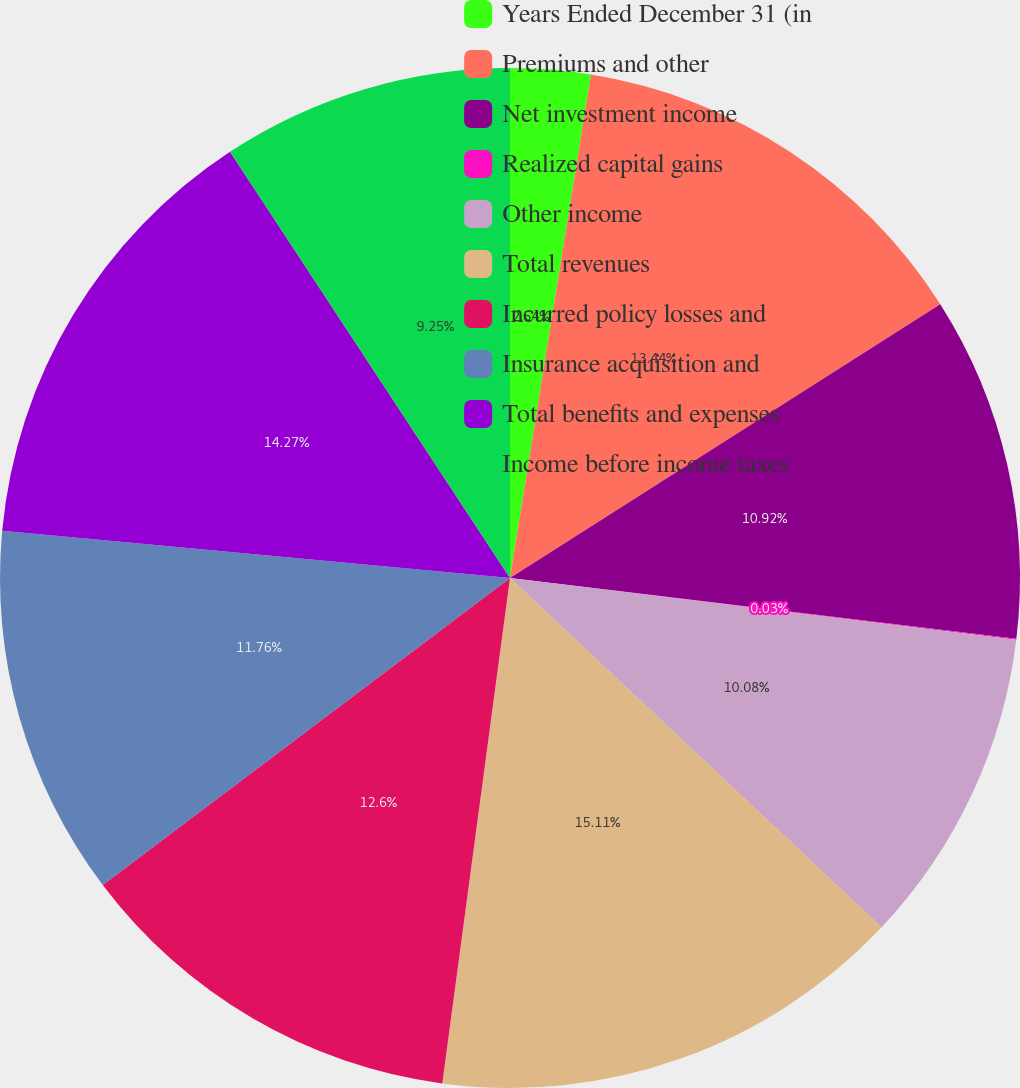<chart> <loc_0><loc_0><loc_500><loc_500><pie_chart><fcel>Years Ended December 31 (in<fcel>Premiums and other<fcel>Net investment income<fcel>Realized capital gains<fcel>Other income<fcel>Total revenues<fcel>Incurred policy losses and<fcel>Insurance acquisition and<fcel>Total benefits and expenses<fcel>Income before income taxes<nl><fcel>2.54%<fcel>13.44%<fcel>10.92%<fcel>0.03%<fcel>10.08%<fcel>15.11%<fcel>12.6%<fcel>11.76%<fcel>14.27%<fcel>9.25%<nl></chart> 